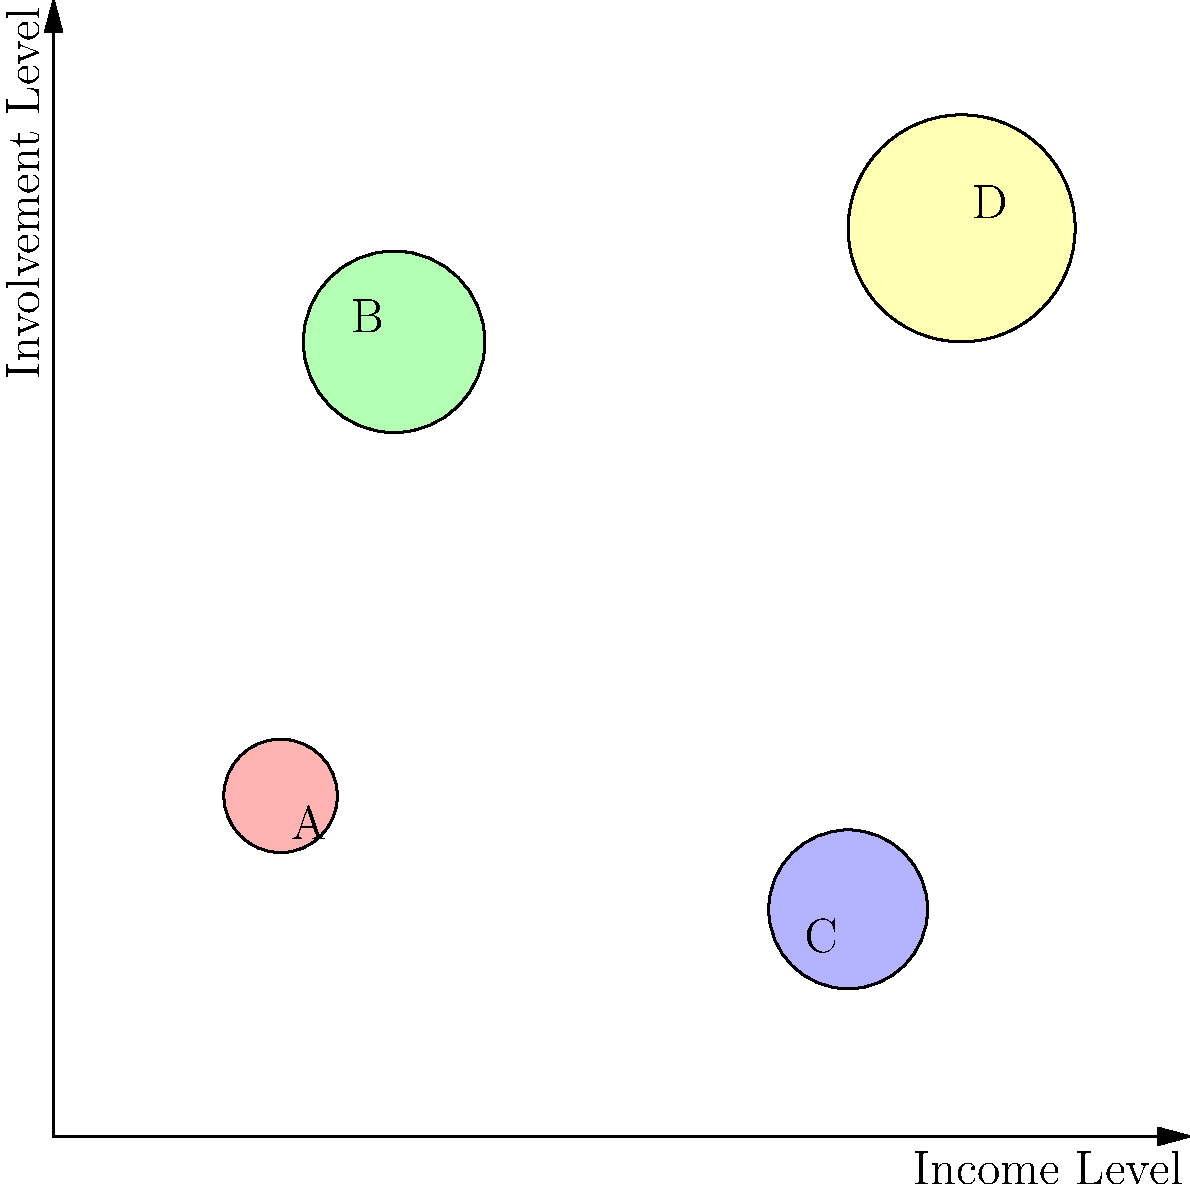Based on the bubble chart showing parent demographics (income level) and involvement levels, which cluster (represented by A, B, C, or D) appears to contradict the common assumption that higher income correlates with higher parent involvement in school programs? To answer this question, we need to analyze the bubble chart and interpret the data it represents:

1. The x-axis represents income level, with lower values indicating lower income and higher values indicating higher income.
2. The y-axis represents involvement level, with lower values indicating lower involvement and higher values indicating higher involvement.
3. The size of each bubble may represent the number of parents in that category, but it's not crucial for answering this specific question.

Let's examine each cluster:

A. Located at (20, 30): Low income, low involvement - This fits the common assumption.
B. Located at (30, 70): Low income, high involvement - This contradicts the common assumption.
C. Located at (70, 20): High income, low involvement - This contradicts the common assumption.
D. Located at (80, 80): High income, high involvement - This fits the common assumption.

The common assumption is that higher income correlates with higher parent involvement. Cluster B (low income, high involvement) clearly contradicts this assumption, as it shows high involvement despite low income.

While cluster C also contradicts the assumption (high income, low involvement), the question asks specifically about which cluster contradicts the assumption that higher income correlates with higher involvement. Cluster B is a more direct contradiction to this specific assumption.
Answer: B 